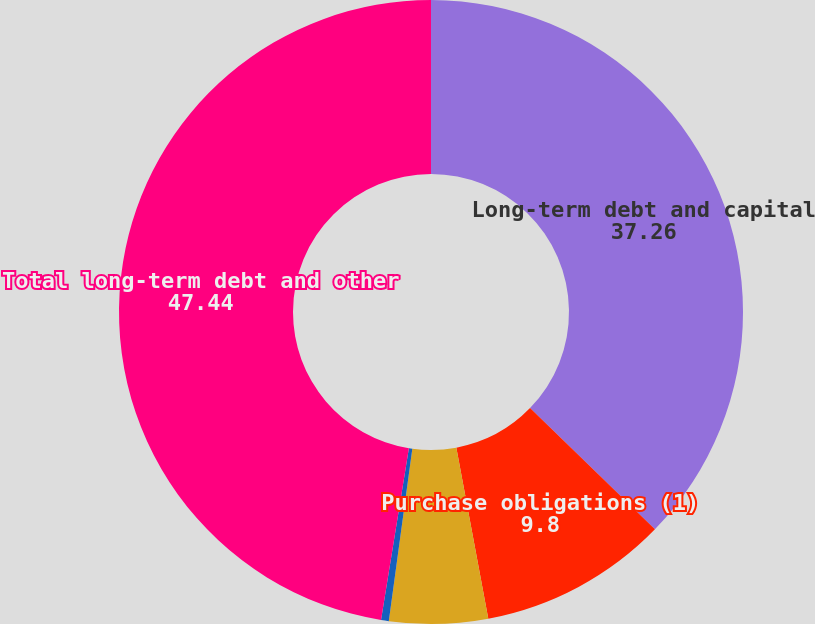<chart> <loc_0><loc_0><loc_500><loc_500><pie_chart><fcel>Long-term debt and capital<fcel>Purchase obligations (1)<fcel>Operating lease obligations<fcel>Other long-term liabilities<fcel>Total long-term debt and other<nl><fcel>37.26%<fcel>9.8%<fcel>5.1%<fcel>0.4%<fcel>47.44%<nl></chart> 